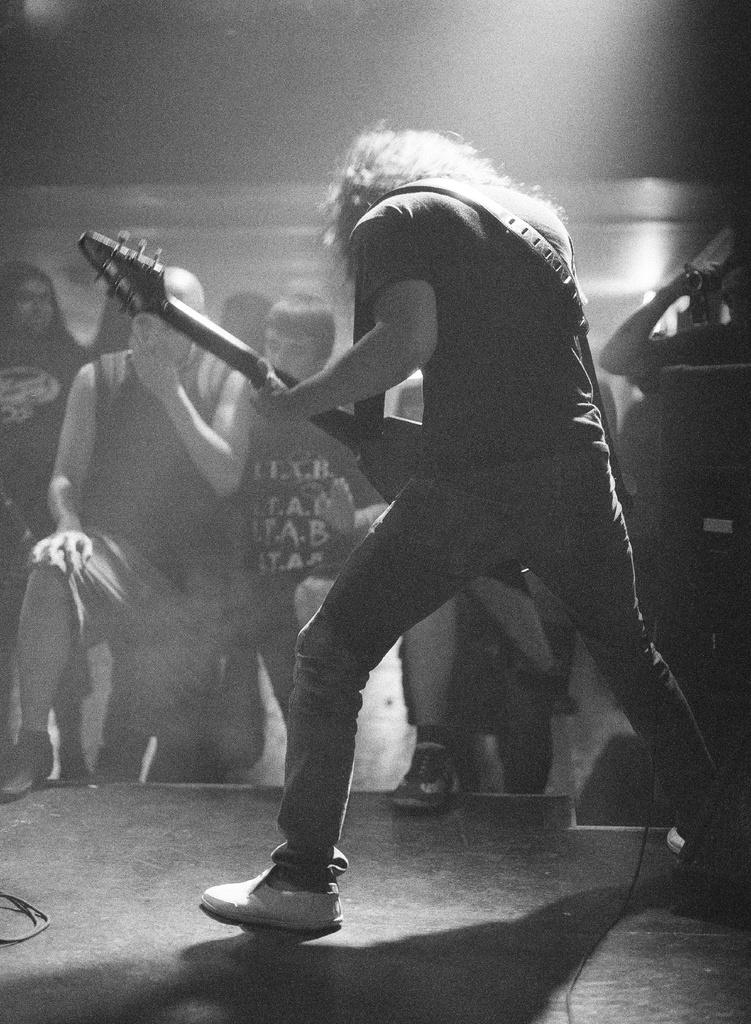What is the main subject of the image? There is a guy playing a guitar in the image. Can you describe the setting of the image? The guy playing a guitar is likely performing for an audience, as there are spectators in the background of the image. What type of yak can be seen in the image? There is no yak present in the image; it features a guy playing a guitar and spectators in the background. 